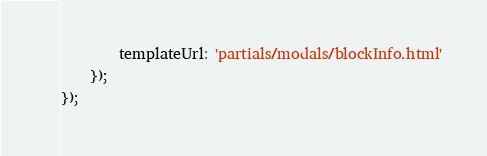Convert code to text. <code><loc_0><loc_0><loc_500><loc_500><_JavaScript_>        templateUrl: 'partials/modals/blockInfo.html'
    });
});
</code> 